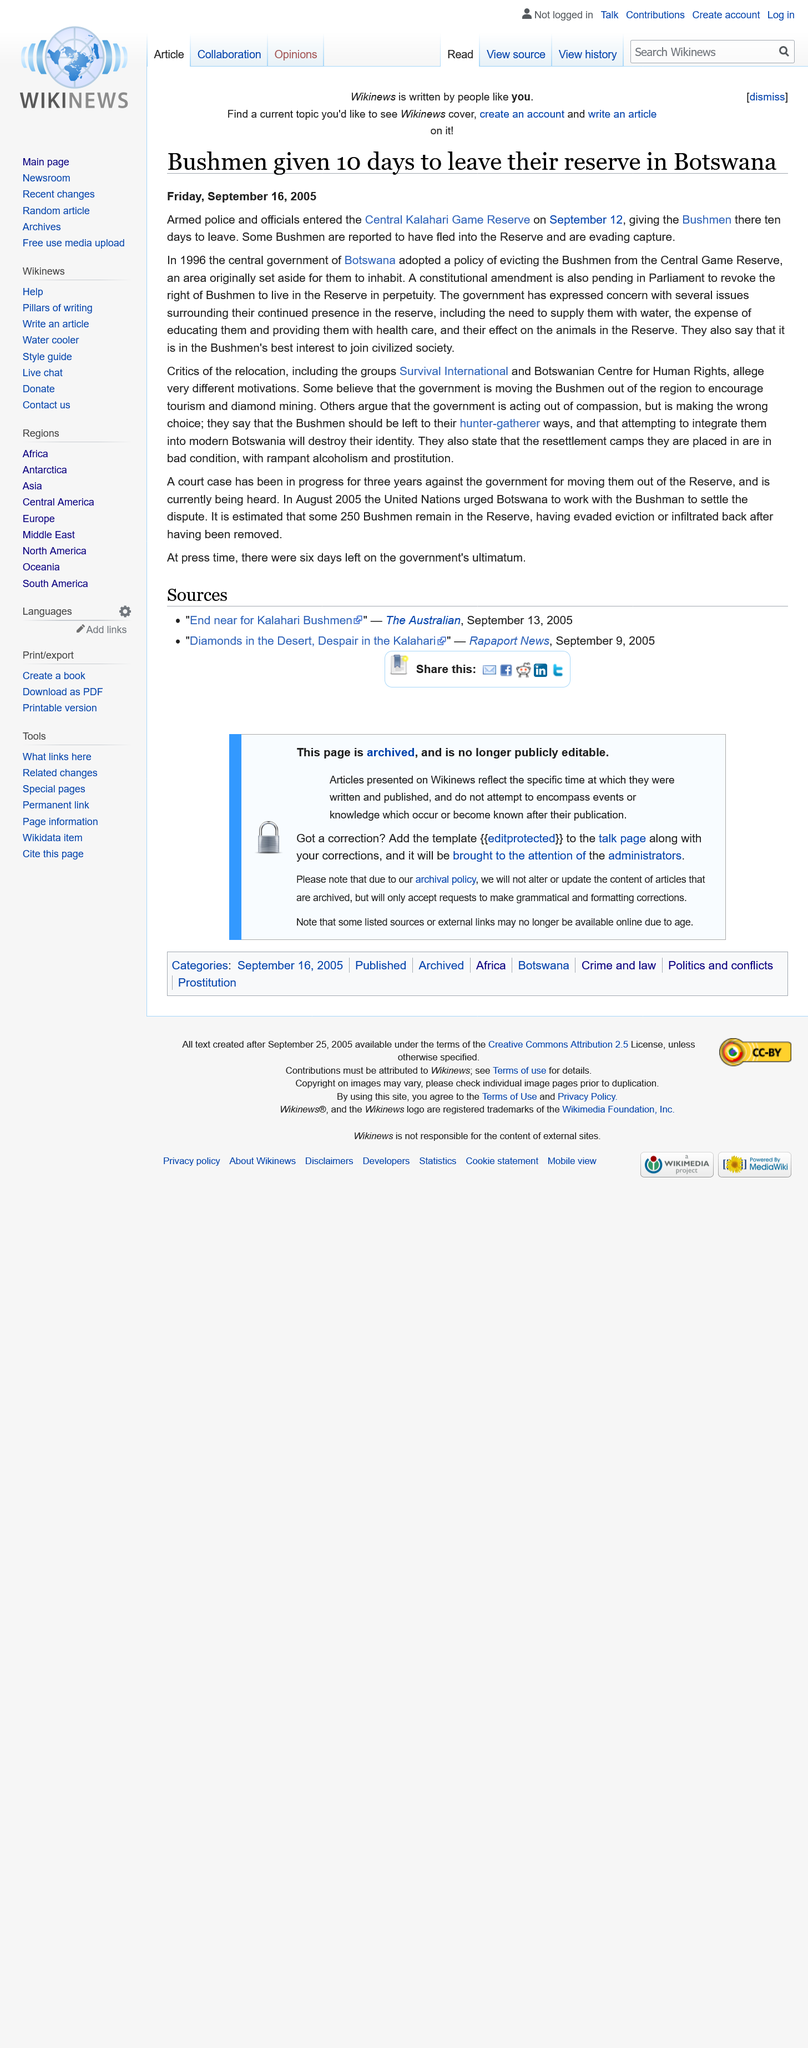List a handful of essential elements in this visual. The Bushmen were given 10 days to leave the area. The Central Kalahari Game Reserve is the reserve's name. It is located in the central part of Botswana and is known for its diverse wildlife, including lions, elephants, and rhinoceroses. On September 12, 2005, the police and officials entered the reserve. 